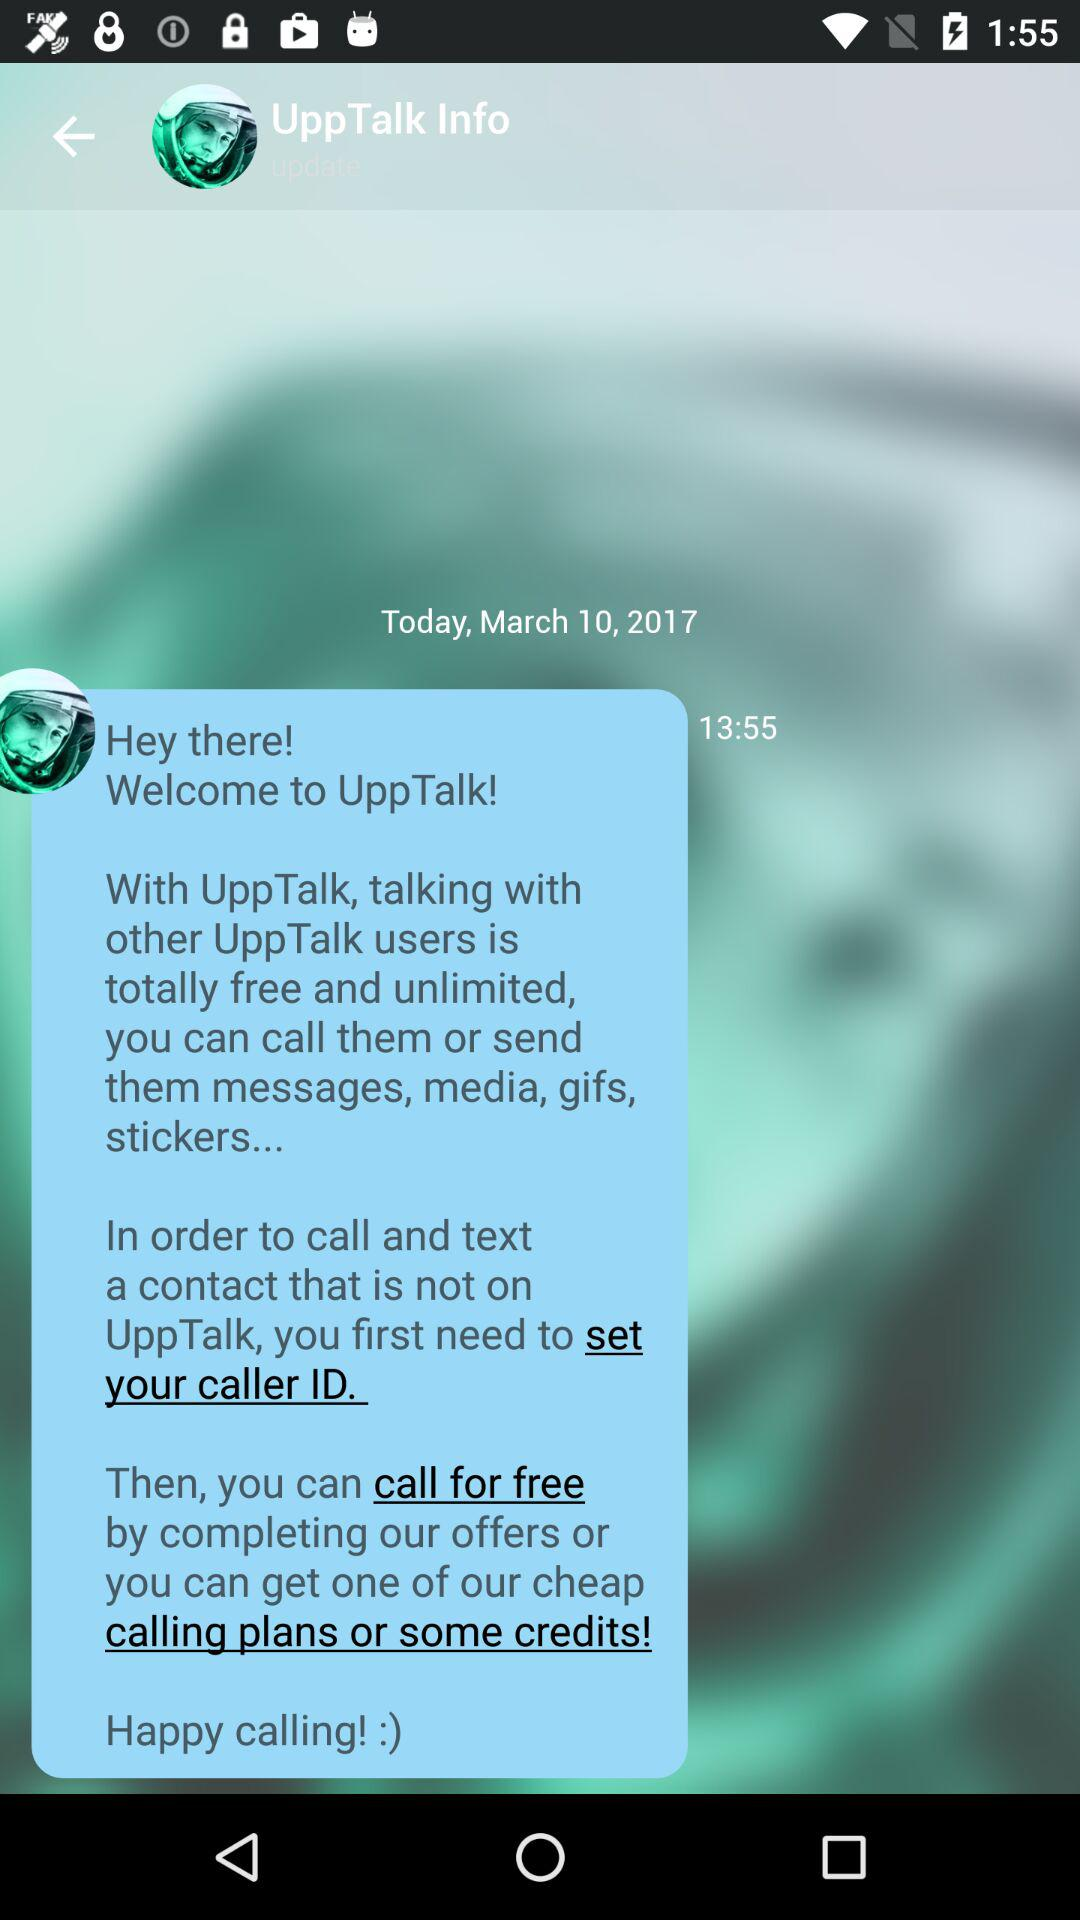What is today's date? It is March 10, 2017. 